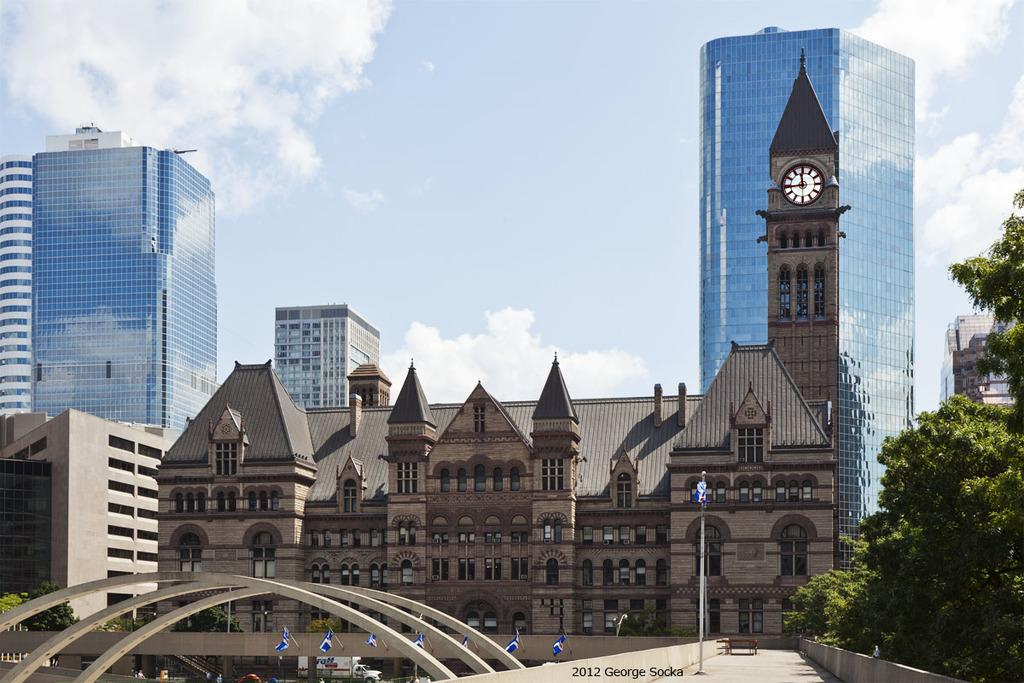What is located in the center of the image? There are buildings in the center of the image. What can be seen in the background of the image? There is sky visible in the background of the image, and there are clouds in the background as well. What type of vegetation is on the right side of the image? There is a tree to the right side of the image. What is the tall, pole-like structure in the image? There is a flagpole in the image. What type of silk is draped over the flagpole in the image? There is no silk present in the image; the flagpole is empty. How many pails of water are visible in the image? There are no pails of water present in the image. 